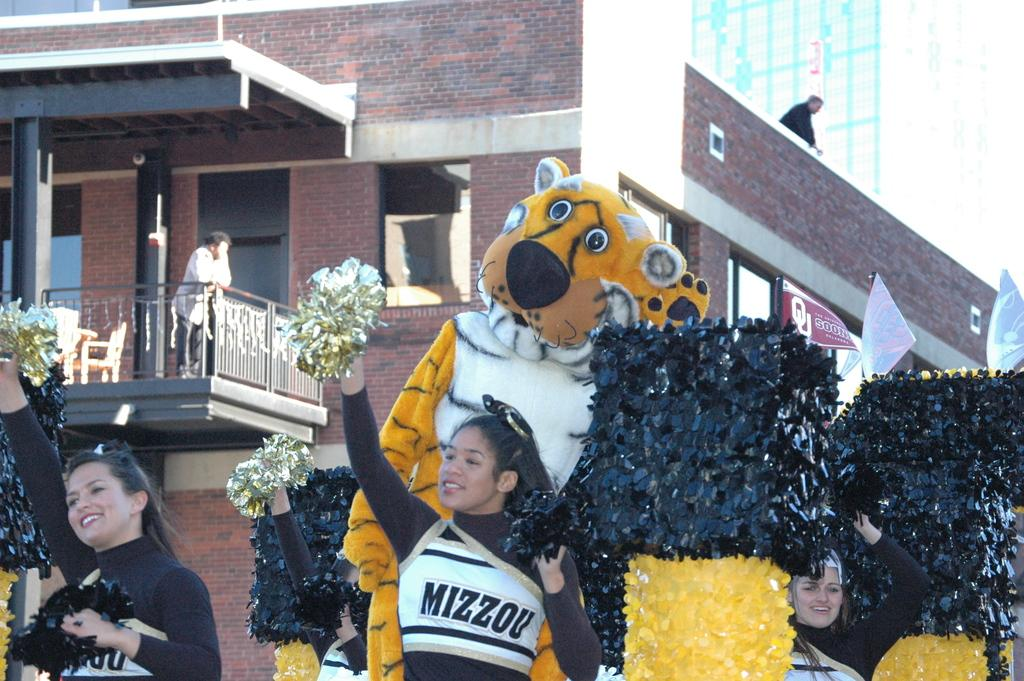<image>
Offer a succinct explanation of the picture presented. A cheerleader with Mizzou on her shirt stands in front of a tiger mascot. 